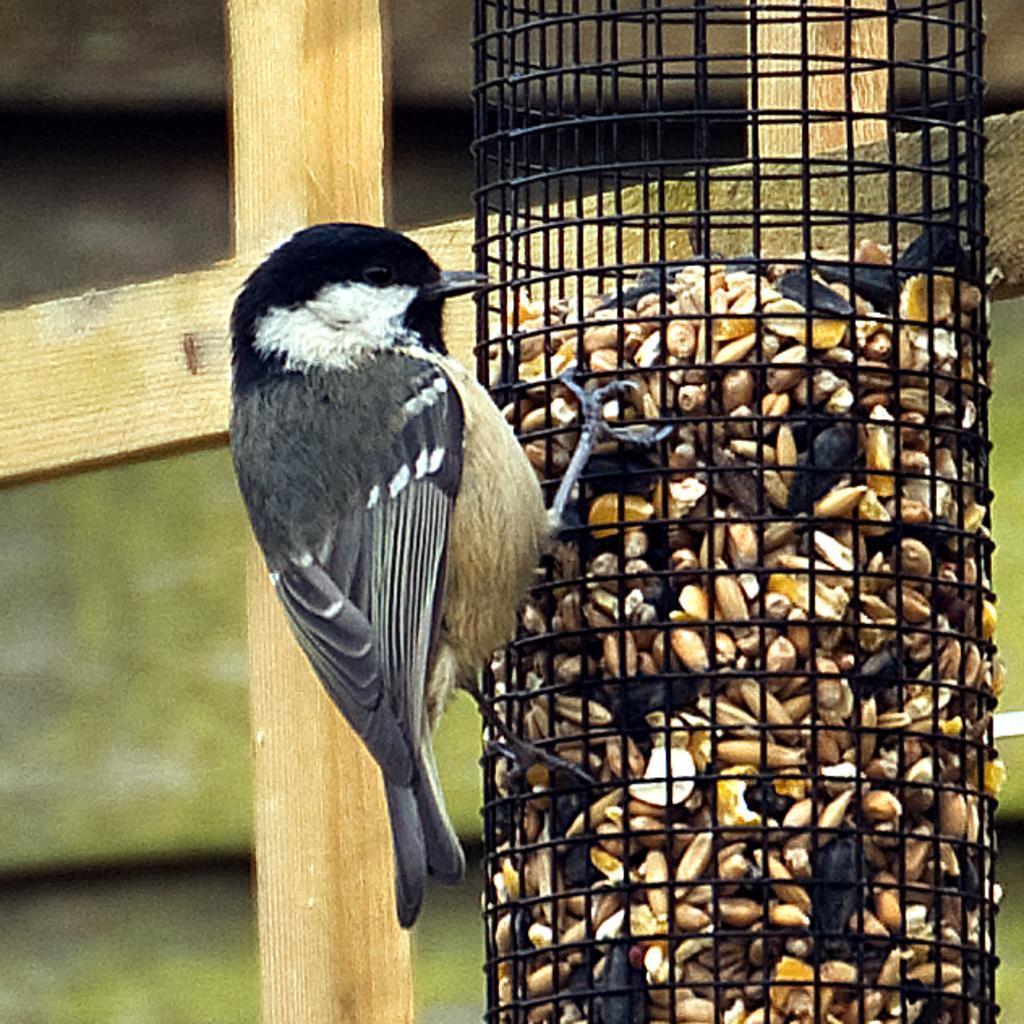Can you describe this image briefly? In this image, we can see seeds in the cage and in the background, there is a fence and we can see a bird. 